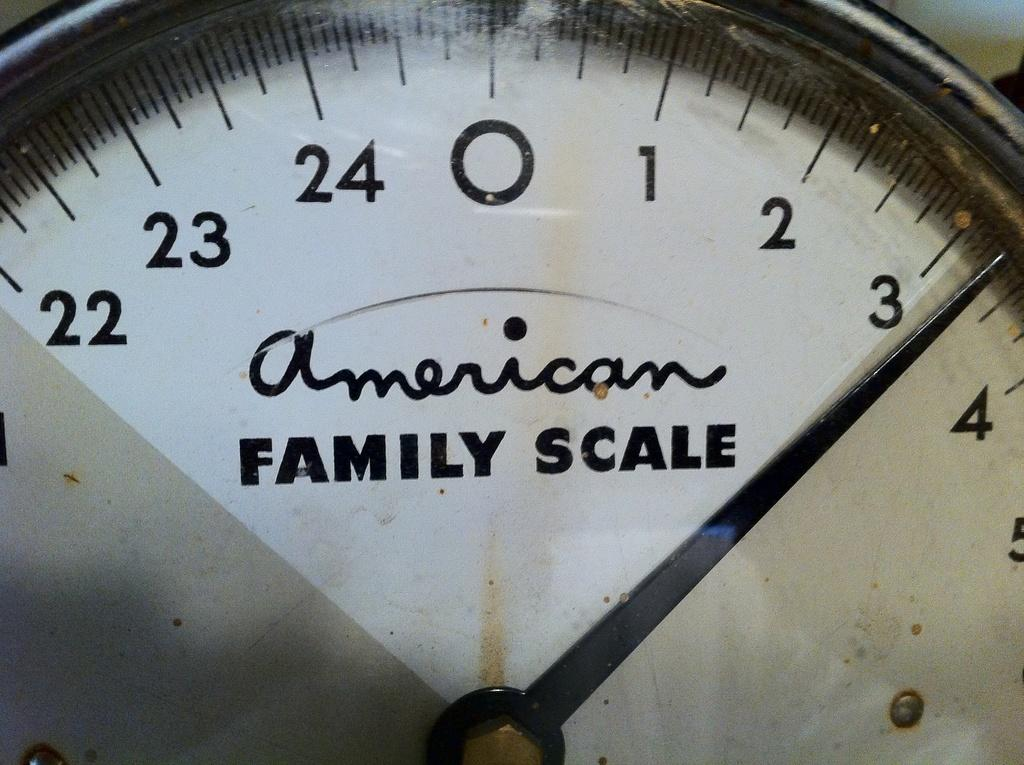What is the main object in the image? There is an indicator in the image. Can you describe the color of the indicator? The indicator is white in color. What type of lock is used to secure the governor's office in the image? There is no lock or governor's office present in the image; it only features an indicator. 